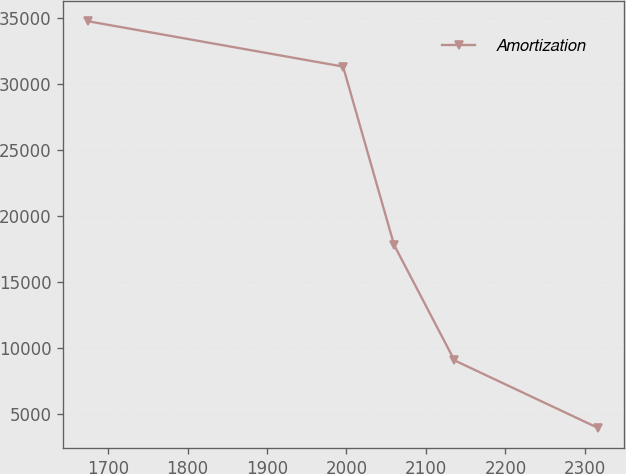Convert chart to OTSL. <chart><loc_0><loc_0><loc_500><loc_500><line_chart><ecel><fcel>Amortization<nl><fcel>1675.32<fcel>34771.8<nl><fcel>1995.76<fcel>31337.8<nl><fcel>2059.91<fcel>17811.9<nl><fcel>2135.81<fcel>9055.54<nl><fcel>2316.83<fcel>3918.48<nl></chart> 